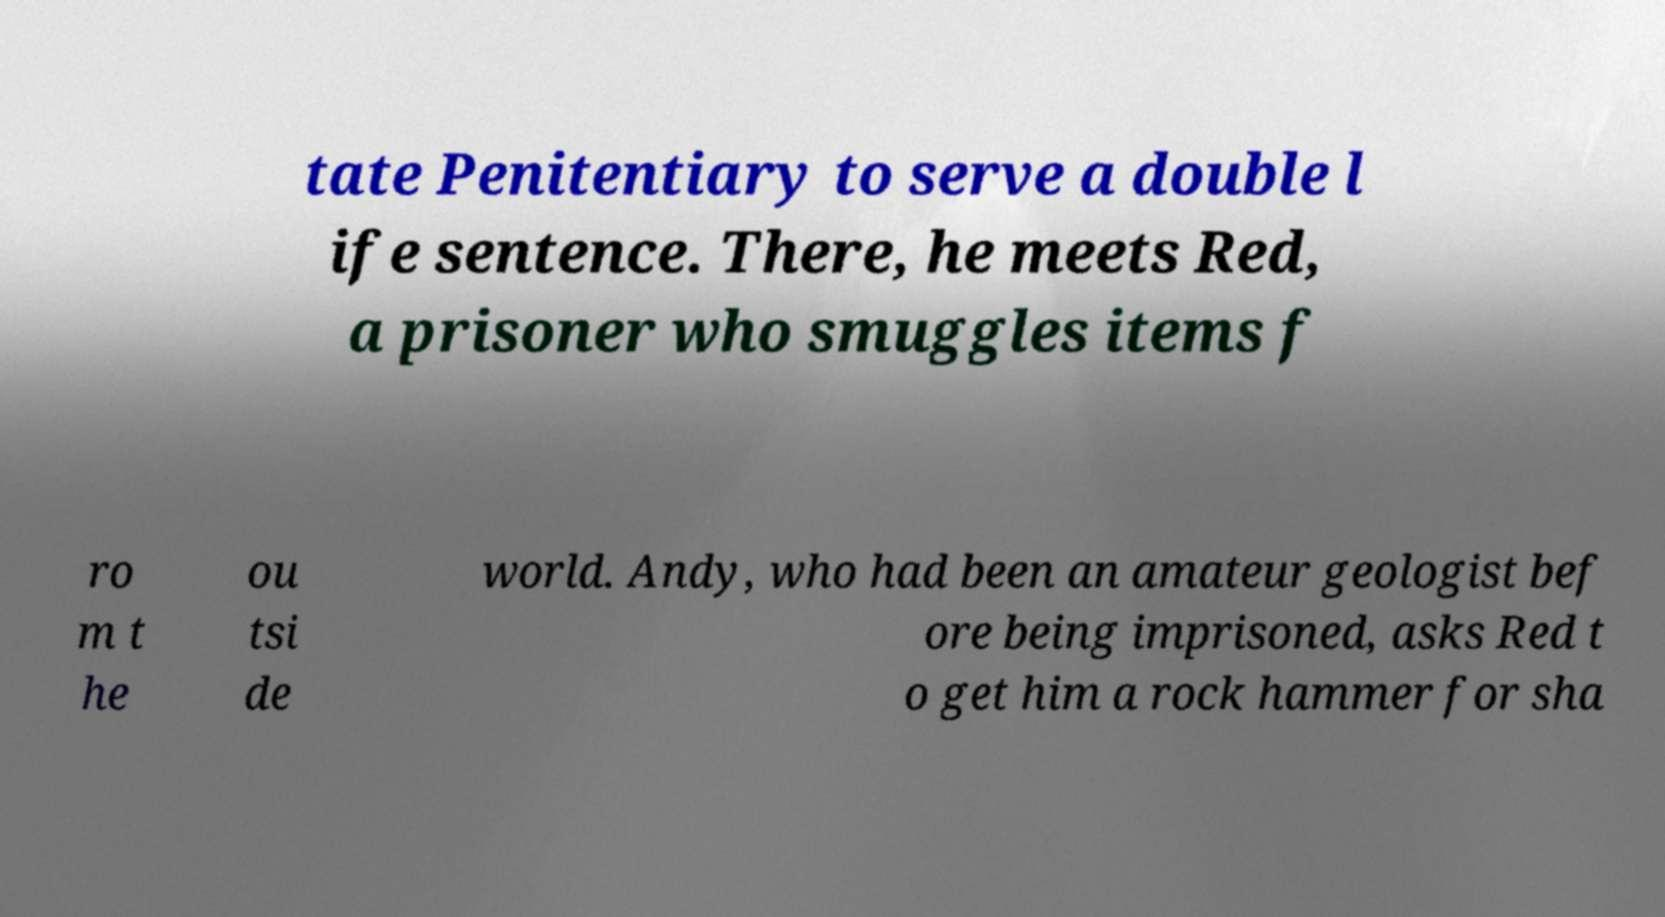Could you assist in decoding the text presented in this image and type it out clearly? tate Penitentiary to serve a double l ife sentence. There, he meets Red, a prisoner who smuggles items f ro m t he ou tsi de world. Andy, who had been an amateur geologist bef ore being imprisoned, asks Red t o get him a rock hammer for sha 